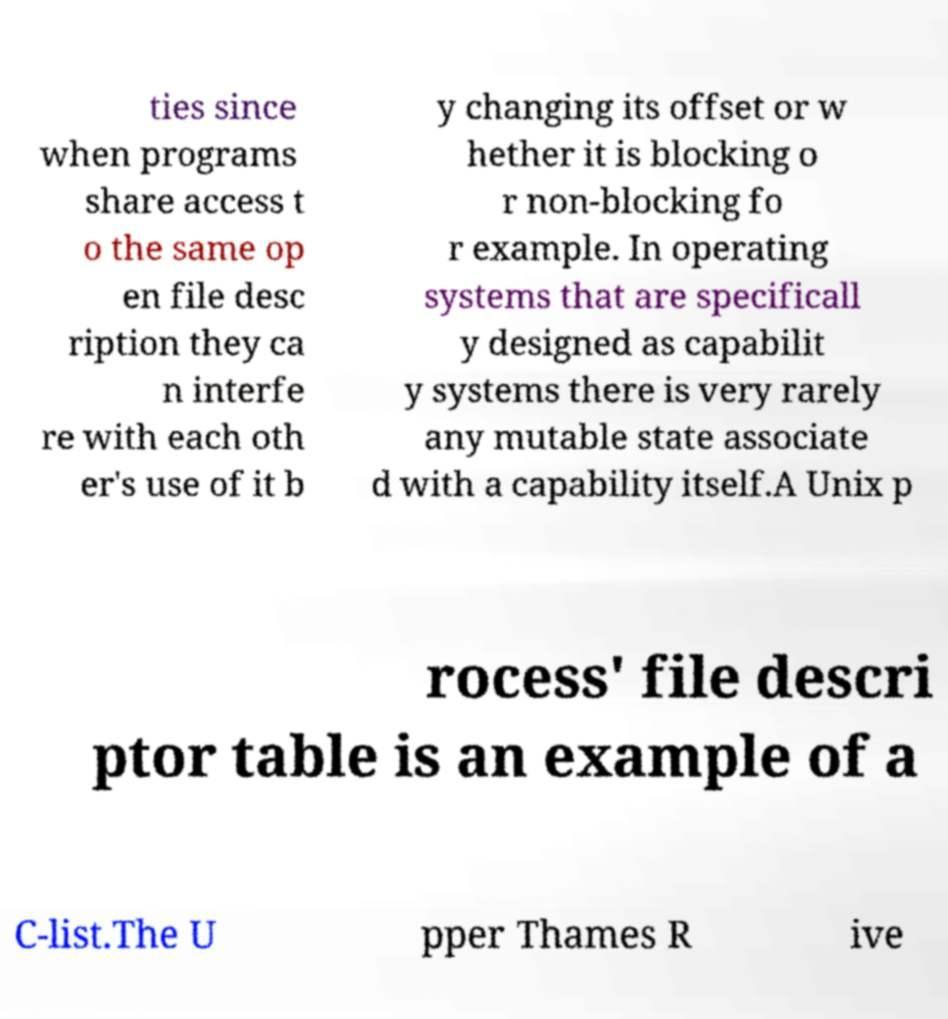Could you extract and type out the text from this image? ties since when programs share access t o the same op en file desc ription they ca n interfe re with each oth er's use of it b y changing its offset or w hether it is blocking o r non-blocking fo r example. In operating systems that are specificall y designed as capabilit y systems there is very rarely any mutable state associate d with a capability itself.A Unix p rocess' file descri ptor table is an example of a C-list.The U pper Thames R ive 